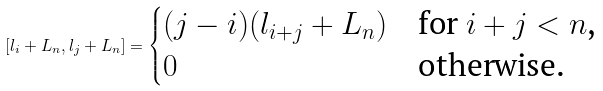Convert formula to latex. <formula><loc_0><loc_0><loc_500><loc_500>[ l _ { i } + L _ { n } , l _ { j } + L _ { n } ] = \begin{cases} ( j - i ) ( l _ { i + j } + L _ { n } ) & \text {for $i+j<n$,} \\ 0 & \text {otherwise.} \end{cases}</formula> 